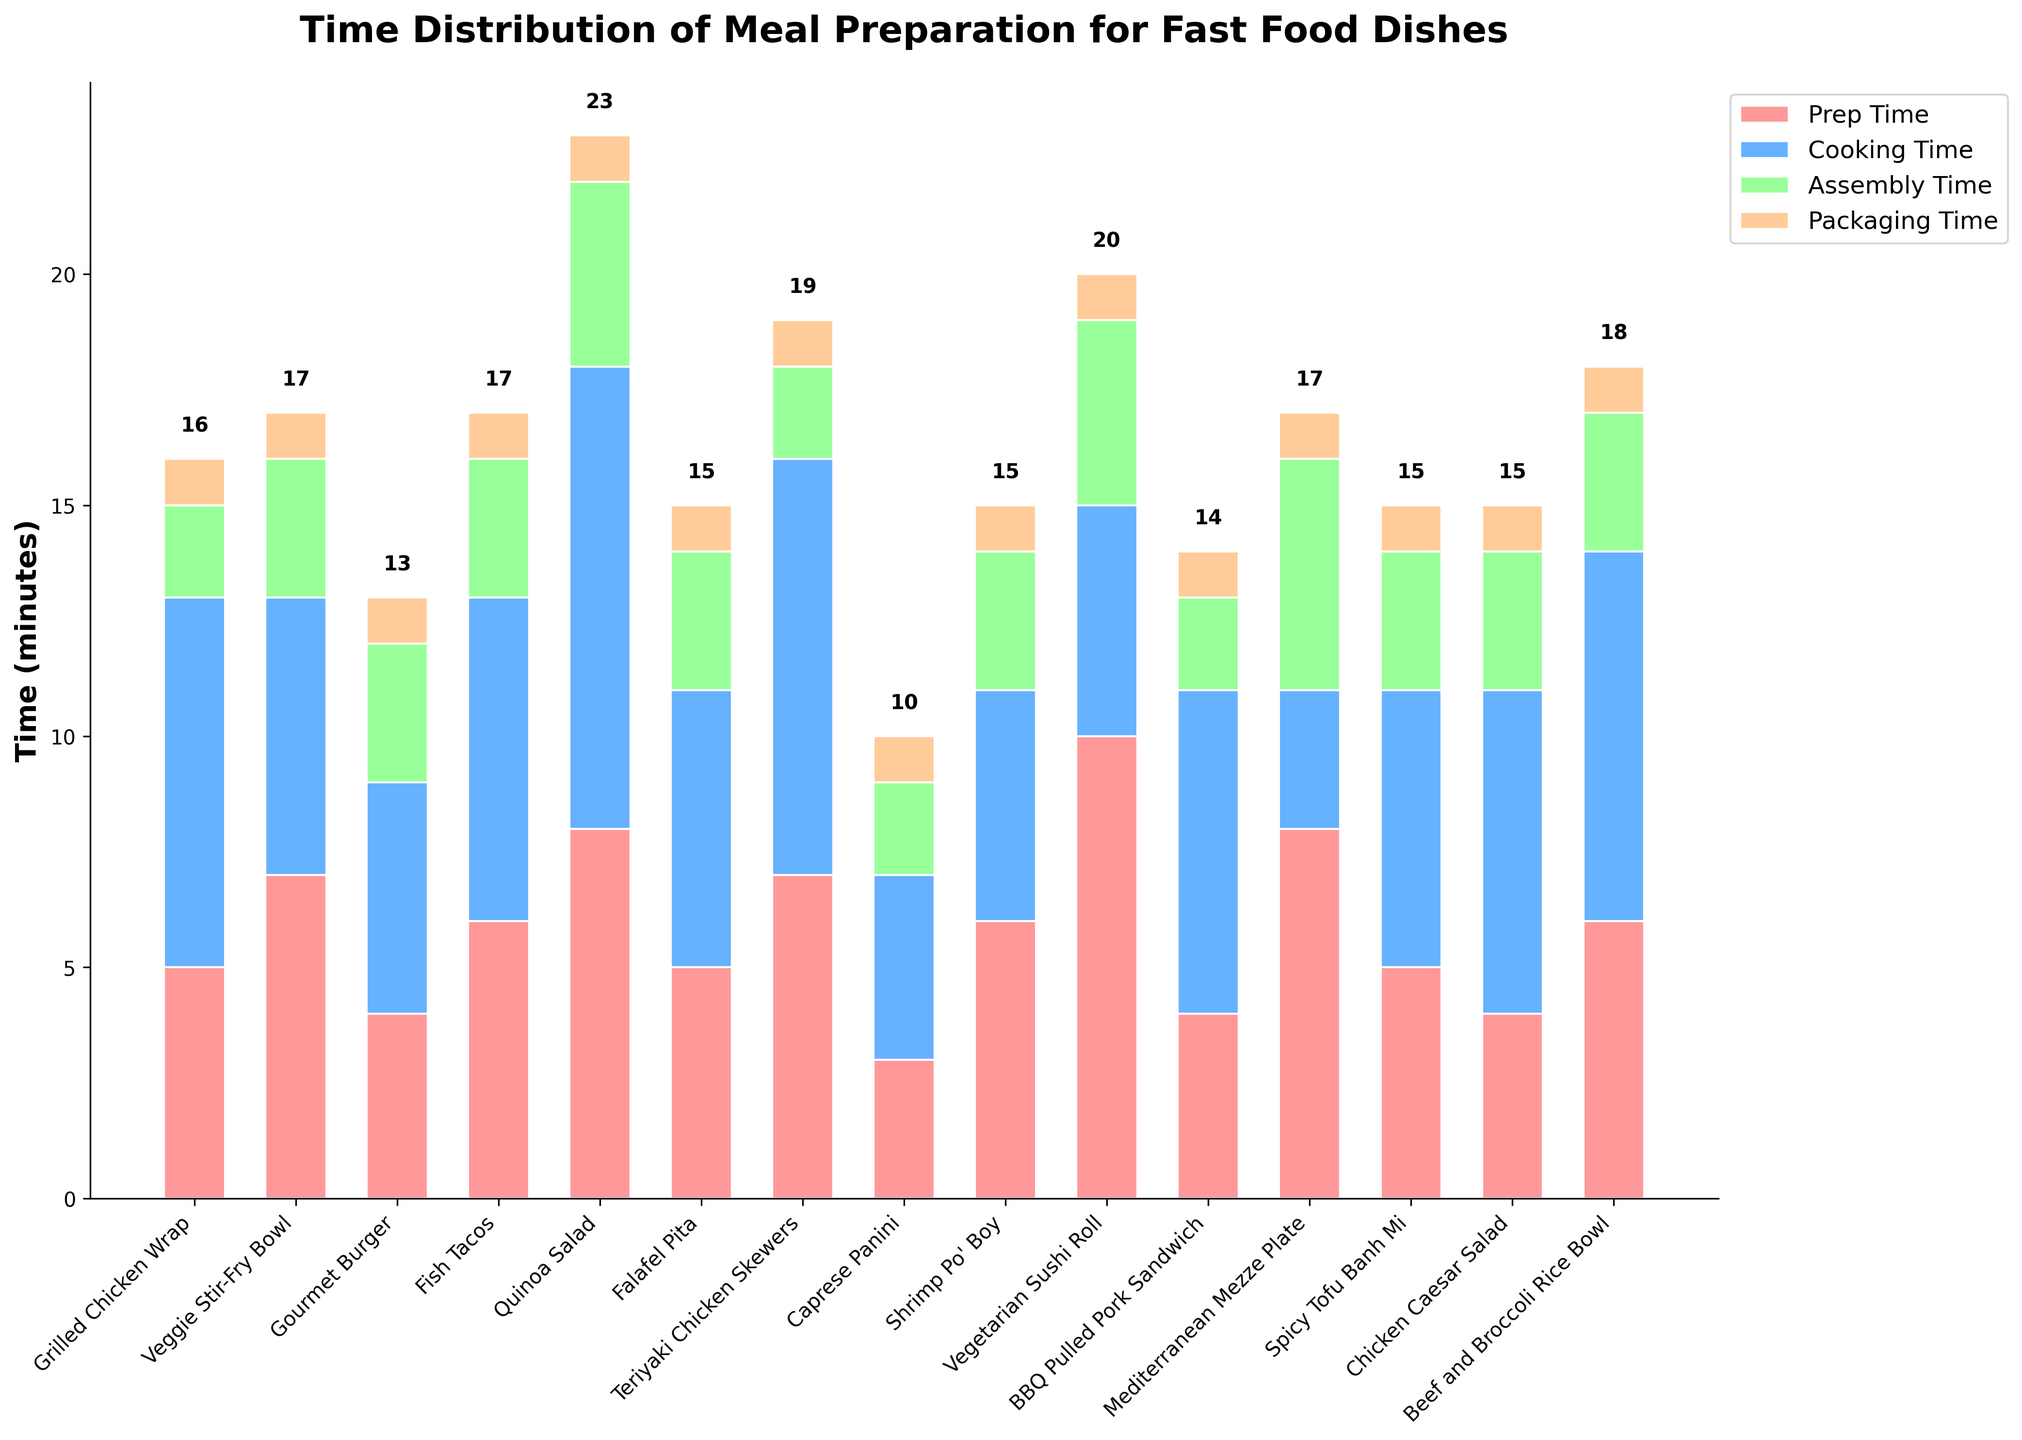Which dish has the longest total meal preparation time? To determine the total meal preparation time for each dish, add the values for prep time, cooking time, assembly time, and packaging time. Compare the sums for all dishes. The dish with the highest sum has the longest total meal preparation time.
Answer: Quinoa Salad Which dish has the shortest prep time? By looking at the height of the red bars representing prep time for each dish, find the shortest bar.
Answer: Caprese Panini What is the difference in total meal preparation time between the Vegetarian Sushi Roll and the Caprese Panini? Add up the prep, cooking, assembly, and packaging times for both dishes. Subtract the smaller total from the larger one: (10+5+4+1) - (3+4+2+1) = 20 - 10 = 10.
Answer: 10 minutes Which dish has the highest cooking time? Look for the blue section of the bars. Identify the tallest blue section corresponding to a dish.
Answer: Quinoa Salad Which dishes have an assembly time of 3 minutes? Identify the green sections of the bars. Note the dishes where the green section represents an assembly time of 3 minutes.
Answer: Veggie Stir-Fry Bowl, Gourmet Burger, Fish Tacos, Falafel Pita, Spicy Tofu Banh Mi, Chicken Caesar Salad, Beef and Broccoli Rice Bowl, Shrimp Po' Boy What is the combined prep and cooking time for the Teriyaki Chicken Skewers? Sum the prep and cooking times: 7 (prep) + 9 (cooking) = 16.
Answer: 16 minutes Compare the total meal preparation time for the BBQ Pulled Pork Sandwich and the Grilled Chicken Wrap. Which has a longer total time? Sum the prep, cooking, assembly, and packaging times for each dish. Compare the totals. BBQ Pulled Pork Sandwich: 4+7+2+1 = 14, Grilled Chicken Wrap: 5+8+2+1 = 16.
Answer: Grilled Chicken Wrap What is the average cooking time across all dishes? Sum the cooking times of all dishes and divide by the number of dishes. (8+6+5+7+10+6+9+4+5+5+7+3+6+7+8)/15 = 98/15 ≈ 6.53.
Answer: Approximately 6.53 minutes 